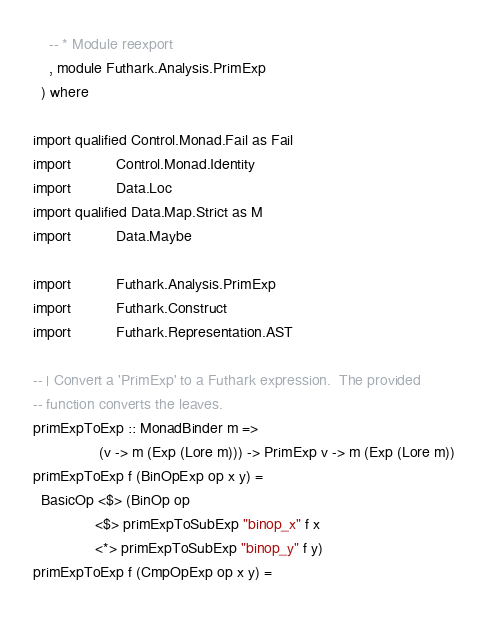<code> <loc_0><loc_0><loc_500><loc_500><_Haskell_>
    -- * Module reexport
    , module Futhark.Analysis.PrimExp
  ) where

import qualified Control.Monad.Fail as Fail
import           Control.Monad.Identity
import           Data.Loc
import qualified Data.Map.Strict as M
import           Data.Maybe

import           Futhark.Analysis.PrimExp
import           Futhark.Construct
import           Futhark.Representation.AST

-- | Convert a 'PrimExp' to a Futhark expression.  The provided
-- function converts the leaves.
primExpToExp :: MonadBinder m =>
                (v -> m (Exp (Lore m))) -> PrimExp v -> m (Exp (Lore m))
primExpToExp f (BinOpExp op x y) =
  BasicOp <$> (BinOp op
               <$> primExpToSubExp "binop_x" f x
               <*> primExpToSubExp "binop_y" f y)
primExpToExp f (CmpOpExp op x y) =</code> 